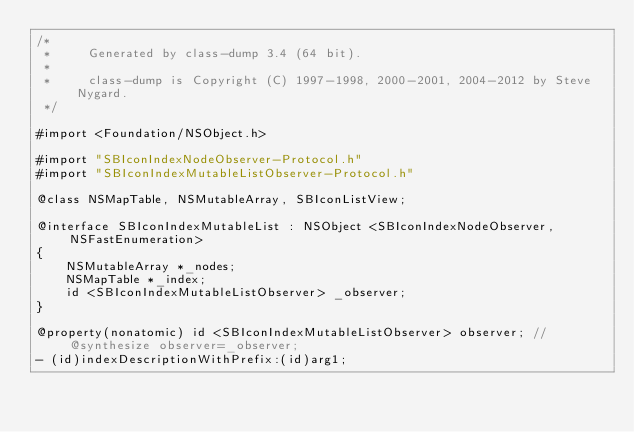<code> <loc_0><loc_0><loc_500><loc_500><_C_>/*
 *     Generated by class-dump 3.4 (64 bit).
 *
 *     class-dump is Copyright (C) 1997-1998, 2000-2001, 2004-2012 by Steve Nygard.
 */

#import <Foundation/NSObject.h>

#import "SBIconIndexNodeObserver-Protocol.h"
#import "SBIconIndexMutableListObserver-Protocol.h"

@class NSMapTable, NSMutableArray, SBIconListView;

@interface SBIconIndexMutableList : NSObject <SBIconIndexNodeObserver, NSFastEnumeration>
{
    NSMutableArray *_nodes;
    NSMapTable *_index;
    id <SBIconIndexMutableListObserver> _observer;
}

@property(nonatomic) id <SBIconIndexMutableListObserver> observer; // @synthesize observer=_observer;
- (id)indexDescriptionWithPrefix:(id)arg1;</code> 